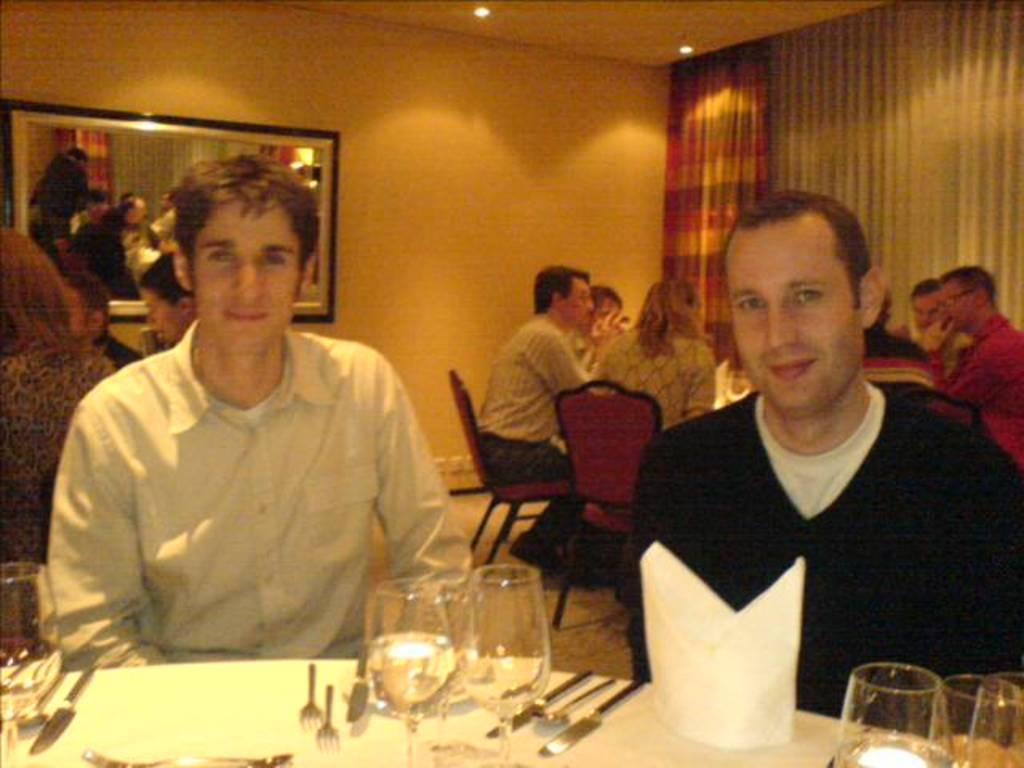What type of space is shown in the image? The image depicts a room. What are the people in the room doing? There are people sitting on chairs in the room. What items can be seen on the table in the image? There are glasses, tissue papers, and utensils such as spoons, forks, and knives on the table. What decorative element is present on the wall? There is a mirror frame on the wall. How many bushes are visible in the image? There are no bushes present in the image; it depicts a room with people sitting on chairs and a table with various items. What type of cup is being used by the people in the image? There is no cup visible in the image; only glasses are mentioned. 